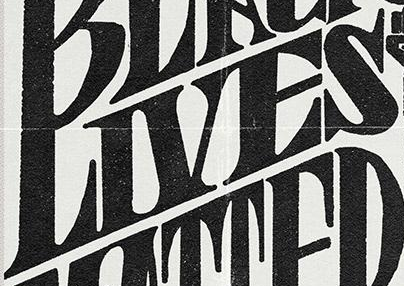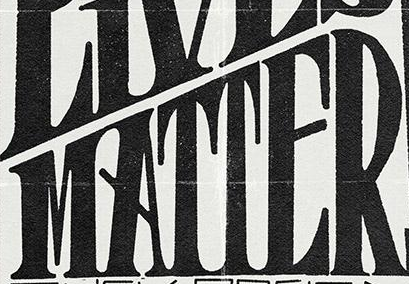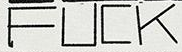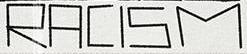What words are shown in these images in order, separated by a semicolon? LIVES; MATTER; FUCK; RACISM 